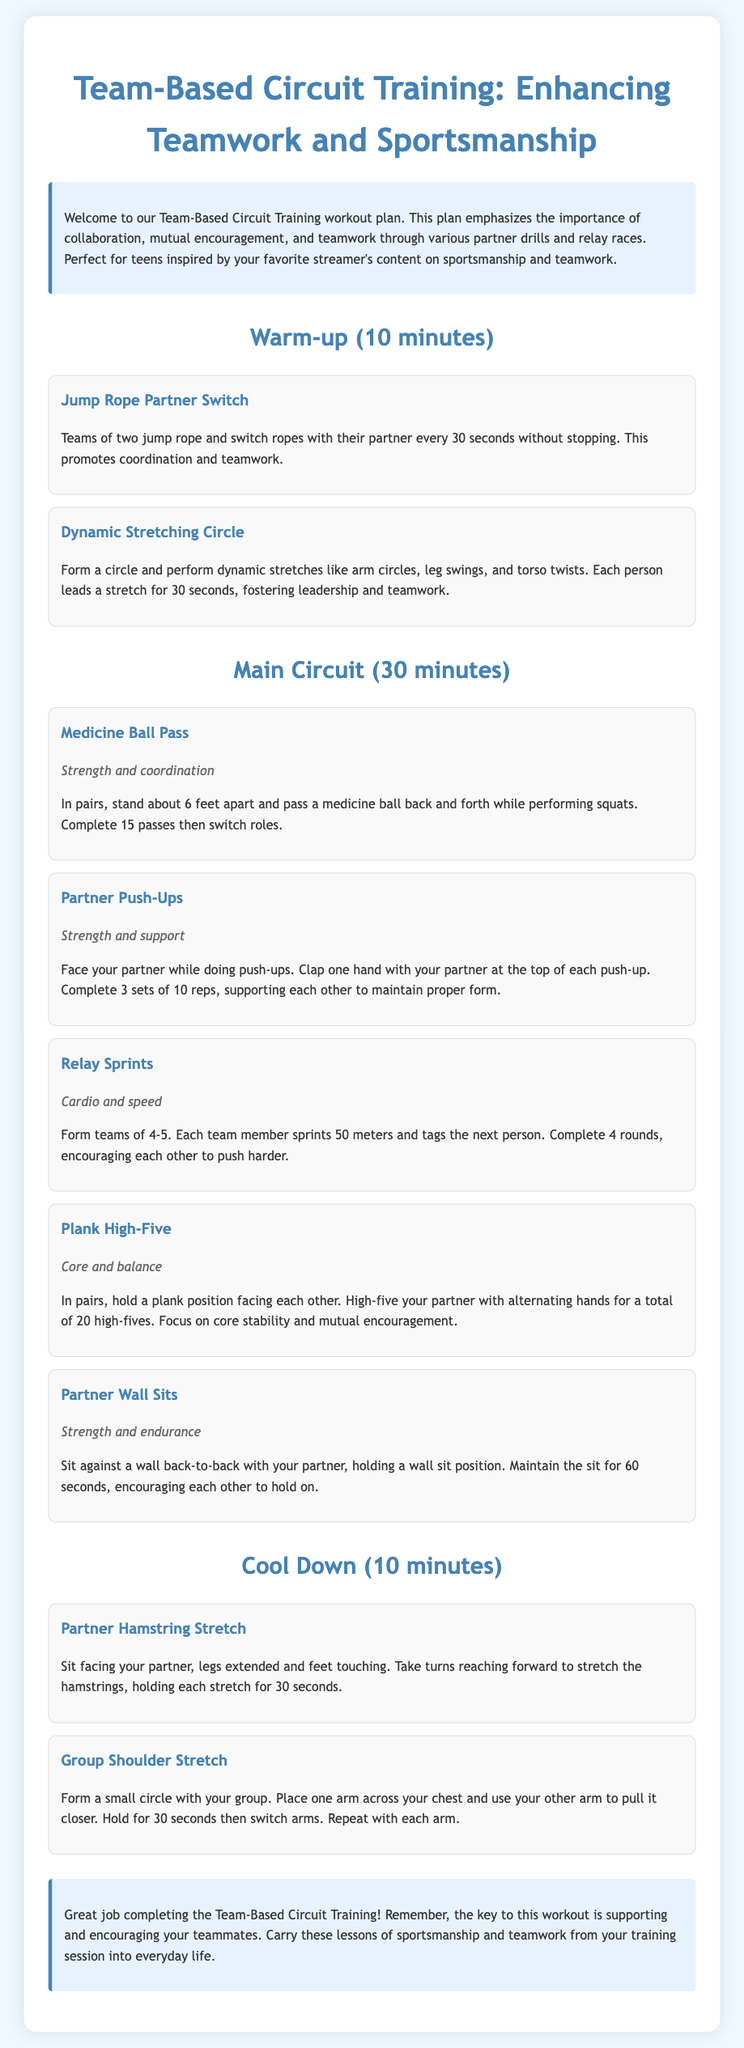What is the duration of the warm-up? The duration of the warm-up section is explicitly stated in the document as 10 minutes.
Answer: 10 minutes How many high-fives are completed in the Plank High-Five exercise? The document indicates that participants must complete a total of 20 high-fives during this activity.
Answer: 20 high-fives What type of exercise is the Medicine Ball Pass classified as? The document describes the Medicine Ball Pass exercise as focusing on strength and coordination.
Answer: Strength and coordination How many team members are required for Relay Sprints? The text specifies that teams should consist of 4-5 members to perform the Relay Sprints.
Answer: 4-5 members Which exercise involves stretching while sitting opposite a partner? The Partner Hamstring Stretch is the exercise that involves partners sitting opposite each other and stretching.
Answer: Partner Hamstring Stretch Why is dynamic stretching performed in a circle? The document explains that dynamic stretching in a circle allows each person to lead a stretch fostering leadership and teamwork.
Answer: Fostering leadership and teamwork What should participants focus on during the Partner Wall Sits? The focus during Partner Wall Sits is on encouraging each other to hold the position for the specified time.
Answer: Encouraging each other What is the main objective of this workout plan? The document emphasizes that the main objective is enhancing teamwork and sportsmanship through various activities.
Answer: Enhancing teamwork and sportsmanship 